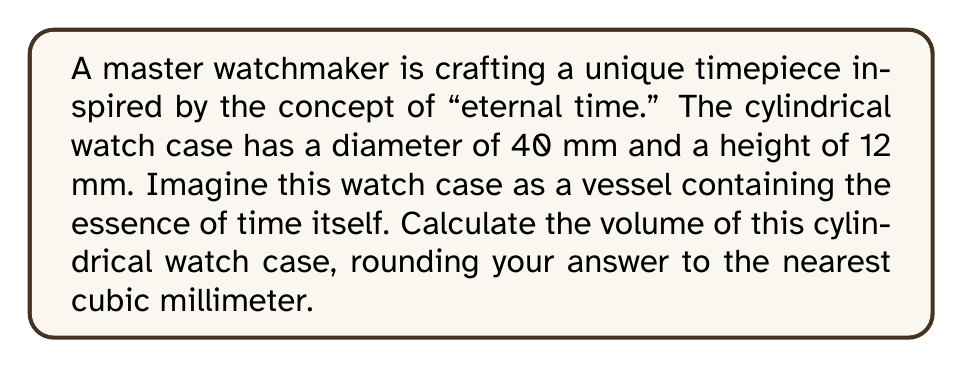Solve this math problem. To calculate the volume of a cylindrical watch case, we need to use the formula for the volume of a cylinder:

$$V = \pi r^2 h$$

Where:
$V$ = volume
$r$ = radius of the base
$h$ = height of the cylinder

Given:
- Diameter = 40 mm
- Height = 12 mm

Step 1: Calculate the radius
The radius is half the diameter:
$r = \frac{40}{2} = 20$ mm

Step 2: Apply the volume formula
$$V = \pi (20\text{ mm})^2 (12\text{ mm})$$

Step 3: Calculate
$$\begin{align*}
V &= \pi (400\text{ mm}^2) (12\text{ mm}) \\
&= 4800\pi\text{ mm}^3 \\
&\approx 15079.64\text{ mm}^3
\end{align*}$$

Step 4: Round to the nearest cubic millimeter
15080 mm³

[asy]
import geometry;

size(200);
real r = 40;
real h = 12;

path base = circle((0,0), r);
path top = circle((0,h), r);

draw(base);
draw(top);
draw((r,0)--(r,h));
draw((-r,0)--(-r,h));
draw((0,0)--(0,h), dashed);

label("40 mm", (0,-r-5), S);
label("12 mm", (r+5,h/2), E);

draw((0,0)--(r,0), arrow=Arrow(TeXHead));
label("20 mm", (r/2,-2), S);
[/asy]
Answer: The volume of the cylindrical watch case is approximately 15080 mm³. 